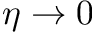<formula> <loc_0><loc_0><loc_500><loc_500>\eta \to 0</formula> 